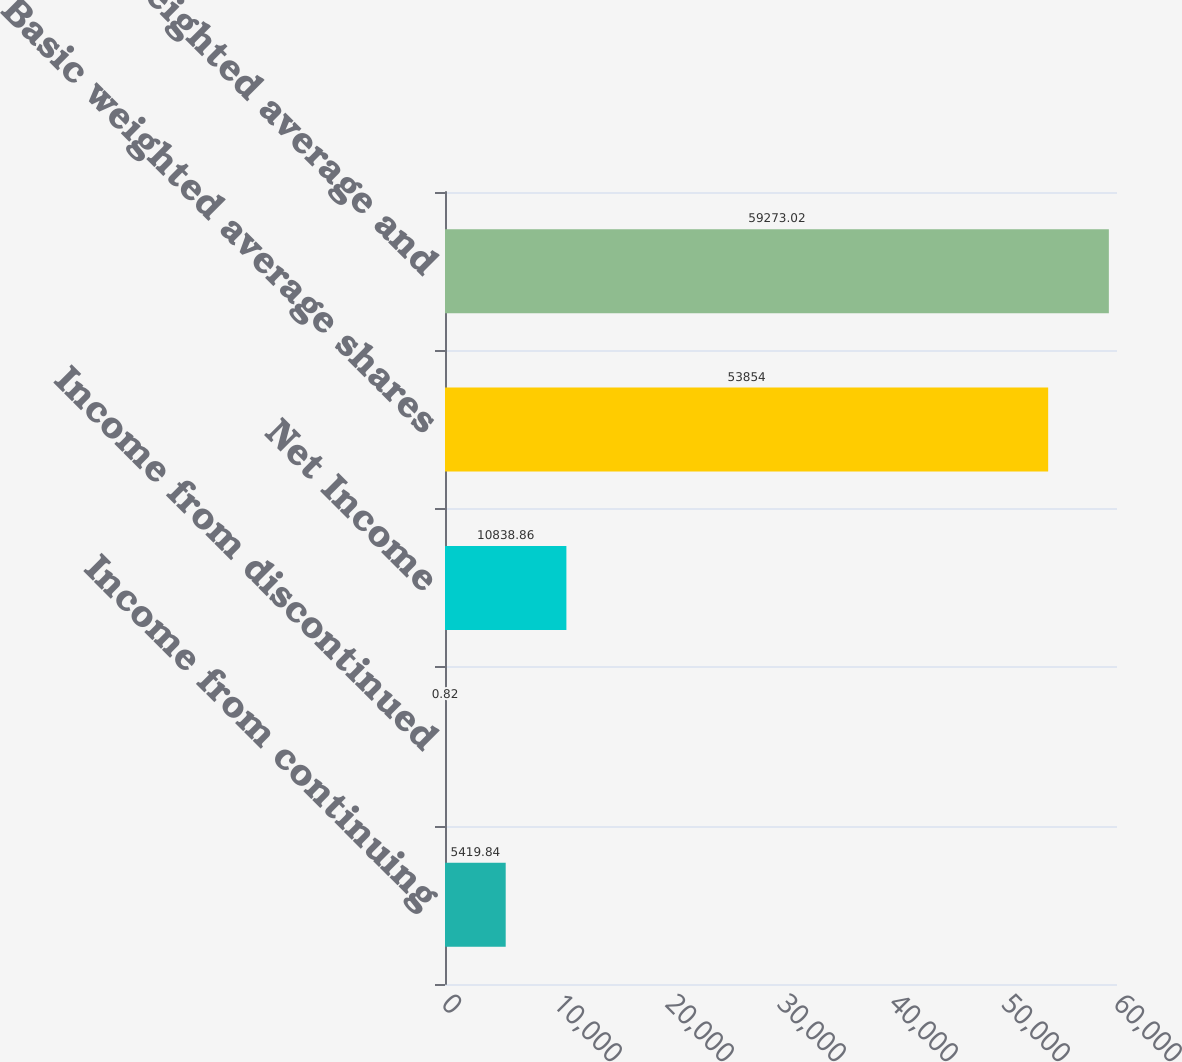Convert chart. <chart><loc_0><loc_0><loc_500><loc_500><bar_chart><fcel>Income from continuing<fcel>Income from discontinued<fcel>Net Income<fcel>Basic weighted average shares<fcel>Diluted weighted average and<nl><fcel>5419.84<fcel>0.82<fcel>10838.9<fcel>53854<fcel>59273<nl></chart> 